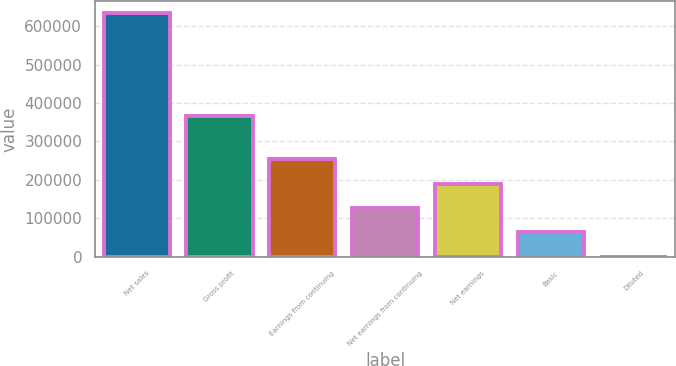Convert chart. <chart><loc_0><loc_0><loc_500><loc_500><bar_chart><fcel>Net sales<fcel>Gross profit<fcel>Earnings from continuing<fcel>Net earnings from continuing<fcel>Net earnings<fcel>Basic<fcel>Diluted<nl><fcel>633586<fcel>365978<fcel>253435<fcel>126718<fcel>190076<fcel>63359.1<fcel>0.5<nl></chart> 